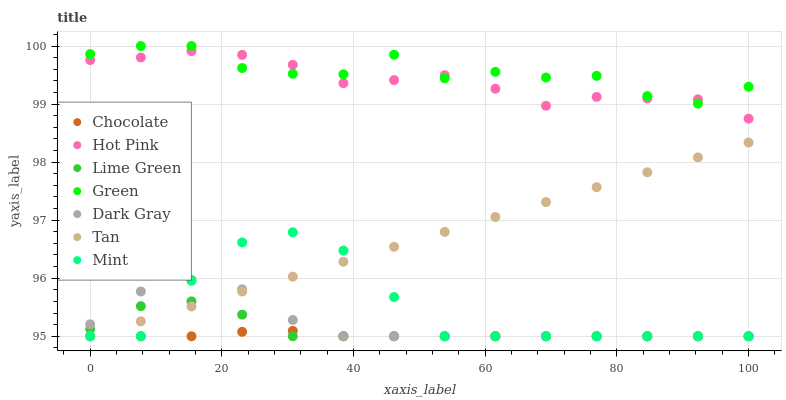Does Chocolate have the minimum area under the curve?
Answer yes or no. Yes. Does Green have the maximum area under the curve?
Answer yes or no. Yes. Does Hot Pink have the minimum area under the curve?
Answer yes or no. No. Does Hot Pink have the maximum area under the curve?
Answer yes or no. No. Is Tan the smoothest?
Answer yes or no. Yes. Is Green the roughest?
Answer yes or no. Yes. Is Hot Pink the smoothest?
Answer yes or no. No. Is Hot Pink the roughest?
Answer yes or no. No. Does Mint have the lowest value?
Answer yes or no. Yes. Does Hot Pink have the lowest value?
Answer yes or no. No. Does Green have the highest value?
Answer yes or no. Yes. Does Hot Pink have the highest value?
Answer yes or no. No. Is Chocolate less than Green?
Answer yes or no. Yes. Is Green greater than Dark Gray?
Answer yes or no. Yes. Does Mint intersect Dark Gray?
Answer yes or no. Yes. Is Mint less than Dark Gray?
Answer yes or no. No. Is Mint greater than Dark Gray?
Answer yes or no. No. Does Chocolate intersect Green?
Answer yes or no. No. 